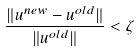Convert formula to latex. <formula><loc_0><loc_0><loc_500><loc_500>\frac { \| u ^ { n e w } - u ^ { o l d } \| } { \| u ^ { o l d } \| } < \zeta</formula> 